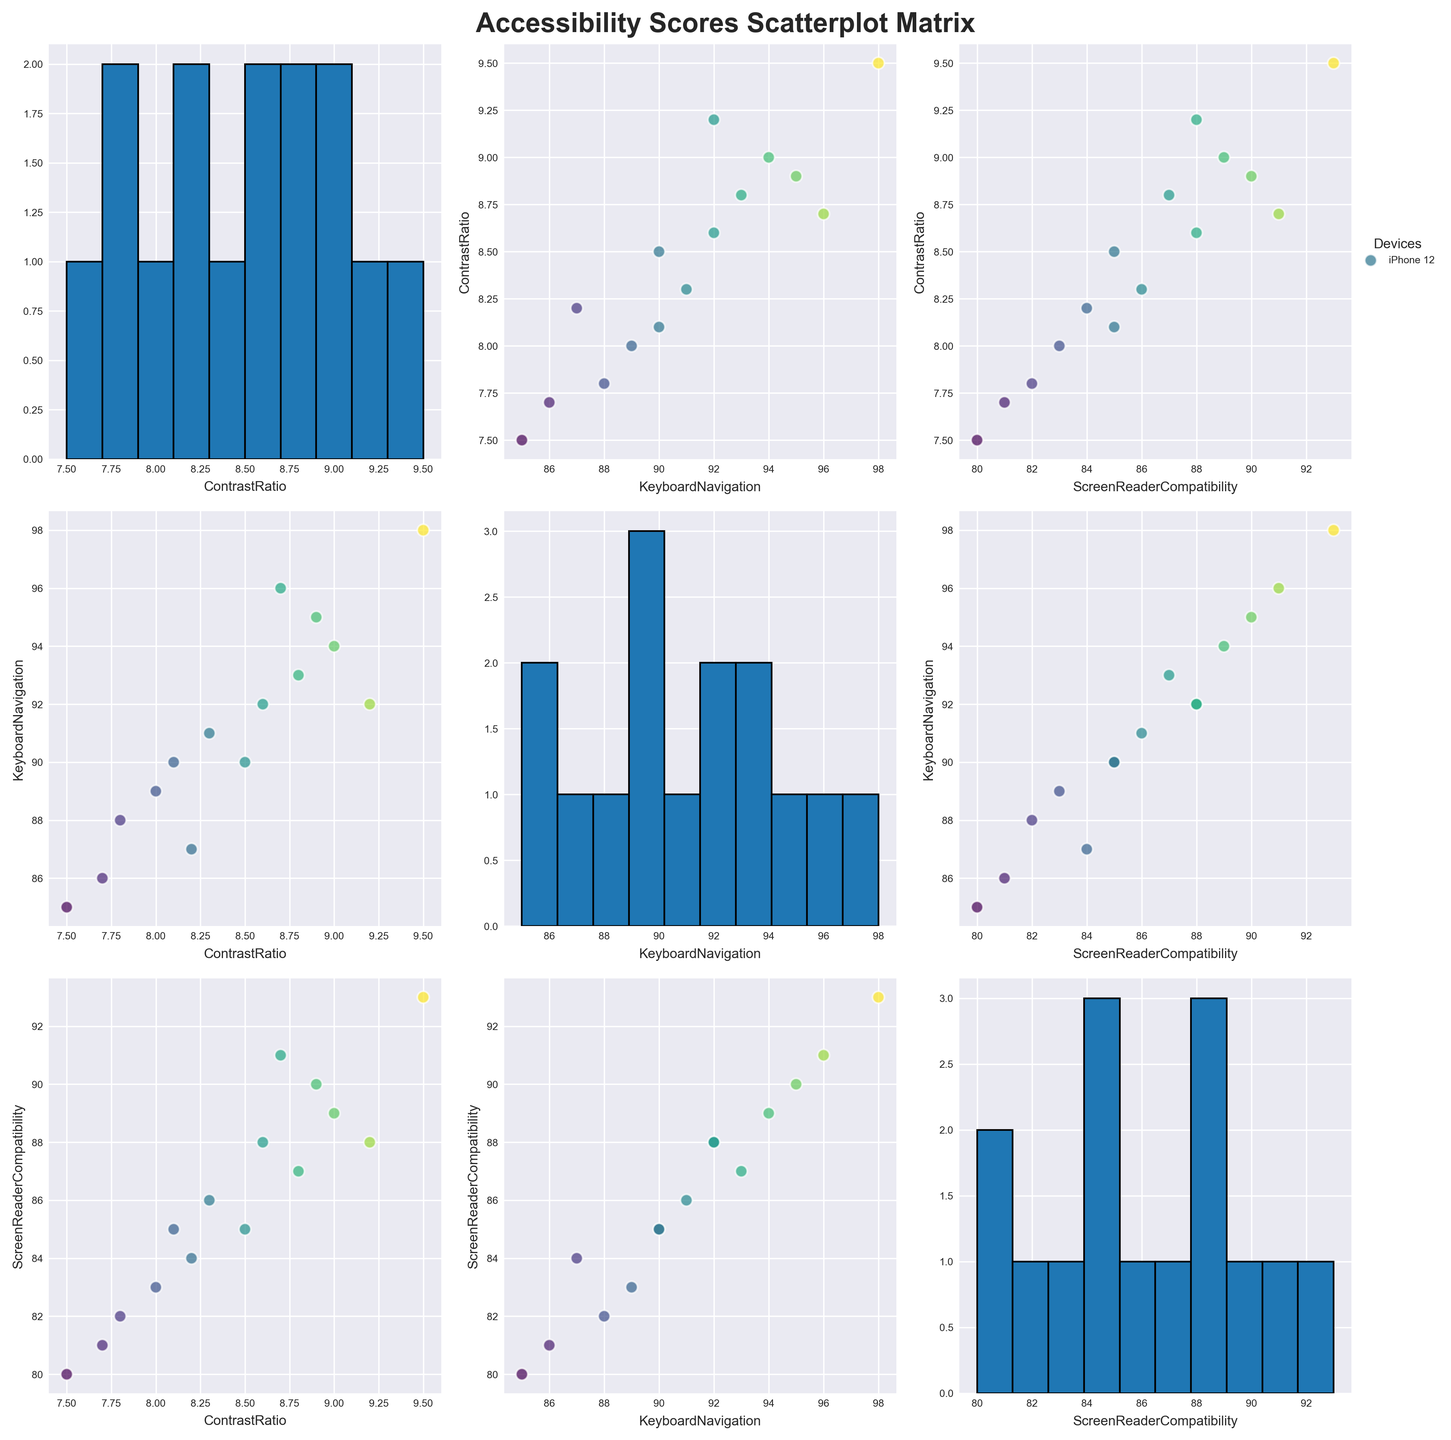What is the title of the scatterplot matrix? The title of a plot is generally found at the top and gives an overview of what the plot is representing. In this scatterplot matrix, it should be located in the central top portion above the plots.
Answer: Accessibility Scores Scatterplot Matrix What are the names of the accessibility features analyzed in the scatterplot matrix? The accessibility features are typically displayed on the axes of the scatterplot matrices, along with their respective names to indicate what data each axis represents.
Answer: Contrast Ratio, Keyboard Navigation, Screen Reader Compatibility How many different devices are represented in the scatterplot matrix? To determine the number of unique devices, one can refer to the color legend which lists all devices. Each marker color represents a different device.
Answer: 15 Which device has the highest value for Screen Reader Compatibility? By examining the individual scatterplots, look for the data point with the highest Screen Reader Compatibility score on its corresponding axis. *Note: The legend might help in identifying the device.*
Answer: MacBook Pro What is the relationship between Contrast Ratio and Keyboard Navigation? To understand the relationship, observe the scatterplot where Contrast Ratio is on one axis and Keyboard Navigation is on the other. Look for trends such as positive or negative correlations, clusters, or spread of the data points.
Answer: Generally positive correlation Which two devices have the most similar scores for Keyboard Navigation? In the scatterplot with Keyboard Navigation on one axis and another metric on the other, look for two data points that are very close to each other on the Keyboard Navigation axis. Checking various plots might be necessary.
Answer: iPad Air and LG Gram 17 Identify the device that shows the most balanced scores across all three features. Balance can be determined by finding a device that appears to be consistently around the middle range for all three features in their respective scatterplots. Observing each scatterplot and assessing the data points' average position would help in identifying such a device.
Answer: Google Pixel 5 Is there a device whose Contrast Ratio is significantly higher, but Keyboard Navigation is lower compared to others? Look for an outlier in the scatterplot of Contrast Ratio vs. Keyboard Navigation where the data point is high on the Contrast Ratio axis but lower on the Keyboard Navigation axis.
Answer: Amazon Fire HD 10 Which feature has the largest range of scores across all devices? Examining the histograms on the diagonal of the scatterplot matrix for each feature can indicate the spread of values. The histogram with the widest spread depicts the feature with the largest range.
Answer: Keyboard Navigation Do any devices show a poor Screen Reader Compatibility but high Keyboard Navigation score? In the scatterplot with Screen Reader Compatibility on one axis and Keyboard Navigation on the other, look for points that are low on the Screen Reader Compatibility axis but high on the Keyboard Navigation axis.
Answer: Amazon Fire HD 10 